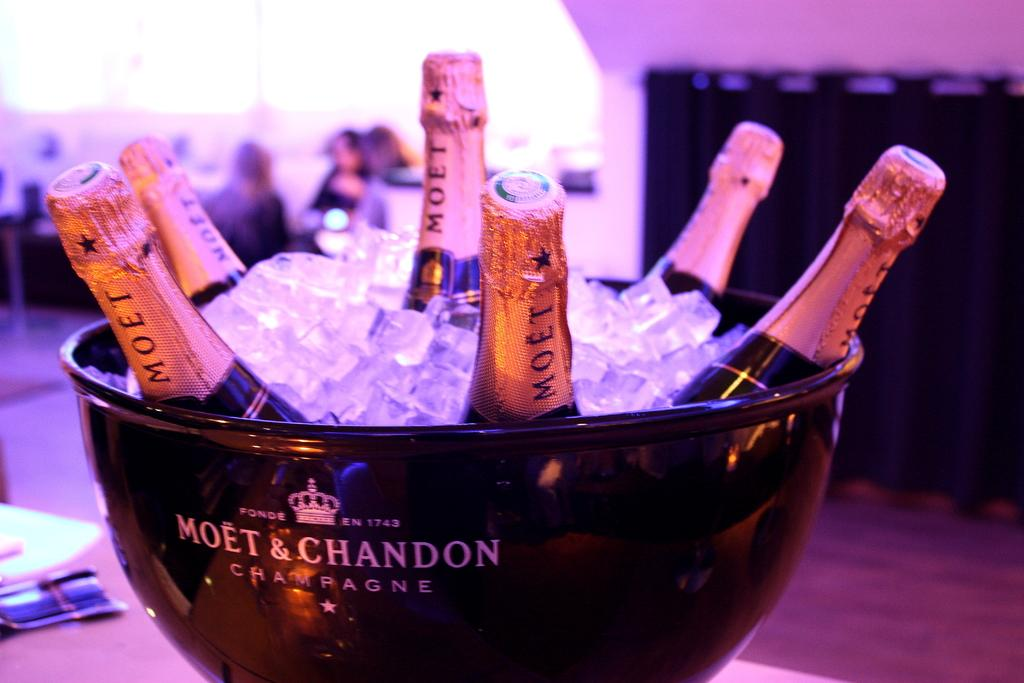<image>
Summarize the visual content of the image. Six bottles of Moet & Chandon champagne are in a tub of ice. 